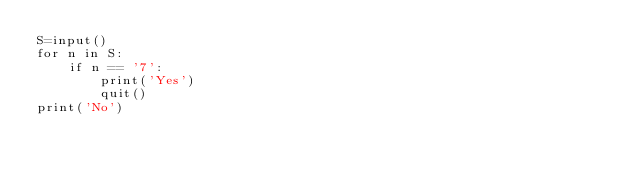Convert code to text. <code><loc_0><loc_0><loc_500><loc_500><_Python_>S=input()
for n in S:
    if n == '7':
        print('Yes')
        quit()
print('No')</code> 